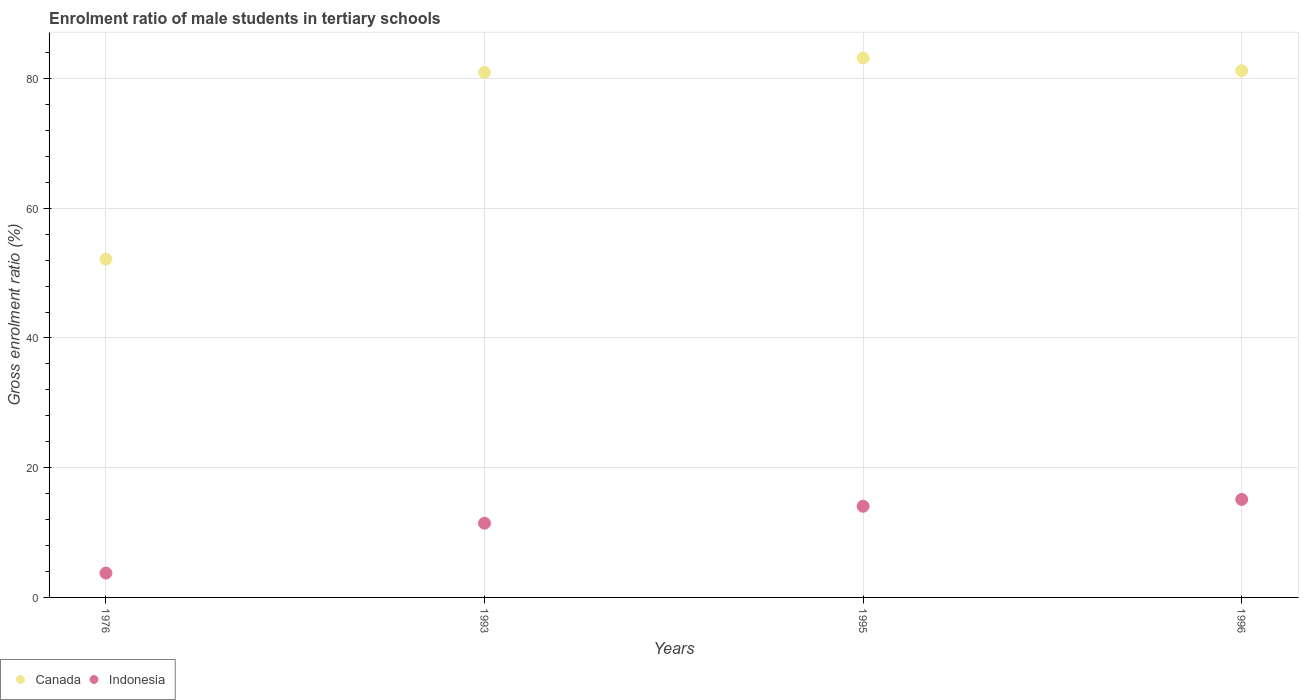What is the enrolment ratio of male students in tertiary schools in Canada in 1996?
Your response must be concise. 81.2. Across all years, what is the maximum enrolment ratio of male students in tertiary schools in Canada?
Ensure brevity in your answer.  83.16. Across all years, what is the minimum enrolment ratio of male students in tertiary schools in Indonesia?
Offer a terse response. 3.75. In which year was the enrolment ratio of male students in tertiary schools in Indonesia maximum?
Provide a succinct answer. 1996. In which year was the enrolment ratio of male students in tertiary schools in Indonesia minimum?
Provide a short and direct response. 1976. What is the total enrolment ratio of male students in tertiary schools in Canada in the graph?
Provide a succinct answer. 297.44. What is the difference between the enrolment ratio of male students in tertiary schools in Canada in 1995 and that in 1996?
Give a very brief answer. 1.96. What is the difference between the enrolment ratio of male students in tertiary schools in Indonesia in 1976 and the enrolment ratio of male students in tertiary schools in Canada in 1996?
Make the answer very short. -77.45. What is the average enrolment ratio of male students in tertiary schools in Indonesia per year?
Keep it short and to the point. 11.09. In the year 1993, what is the difference between the enrolment ratio of male students in tertiary schools in Indonesia and enrolment ratio of male students in tertiary schools in Canada?
Offer a terse response. -69.49. In how many years, is the enrolment ratio of male students in tertiary schools in Canada greater than 40 %?
Ensure brevity in your answer.  4. What is the ratio of the enrolment ratio of male students in tertiary schools in Indonesia in 1976 to that in 1996?
Your answer should be compact. 0.25. Is the difference between the enrolment ratio of male students in tertiary schools in Indonesia in 1976 and 1993 greater than the difference between the enrolment ratio of male students in tertiary schools in Canada in 1976 and 1993?
Your response must be concise. Yes. What is the difference between the highest and the second highest enrolment ratio of male students in tertiary schools in Canada?
Offer a terse response. 1.96. What is the difference between the highest and the lowest enrolment ratio of male students in tertiary schools in Canada?
Keep it short and to the point. 31. In how many years, is the enrolment ratio of male students in tertiary schools in Indonesia greater than the average enrolment ratio of male students in tertiary schools in Indonesia taken over all years?
Your response must be concise. 3. Does the enrolment ratio of male students in tertiary schools in Canada monotonically increase over the years?
Your answer should be very brief. No. How many dotlines are there?
Give a very brief answer. 2. What is the difference between two consecutive major ticks on the Y-axis?
Offer a terse response. 20. Are the values on the major ticks of Y-axis written in scientific E-notation?
Provide a succinct answer. No. Where does the legend appear in the graph?
Your response must be concise. Bottom left. How are the legend labels stacked?
Provide a succinct answer. Horizontal. What is the title of the graph?
Provide a succinct answer. Enrolment ratio of male students in tertiary schools. What is the label or title of the X-axis?
Provide a succinct answer. Years. What is the Gross enrolment ratio (%) in Canada in 1976?
Keep it short and to the point. 52.16. What is the Gross enrolment ratio (%) in Indonesia in 1976?
Provide a succinct answer. 3.75. What is the Gross enrolment ratio (%) in Canada in 1993?
Your response must be concise. 80.93. What is the Gross enrolment ratio (%) in Indonesia in 1993?
Your answer should be very brief. 11.44. What is the Gross enrolment ratio (%) of Canada in 1995?
Offer a terse response. 83.16. What is the Gross enrolment ratio (%) in Indonesia in 1995?
Offer a terse response. 14.06. What is the Gross enrolment ratio (%) of Canada in 1996?
Give a very brief answer. 81.2. What is the Gross enrolment ratio (%) in Indonesia in 1996?
Offer a very short reply. 15.11. Across all years, what is the maximum Gross enrolment ratio (%) in Canada?
Your answer should be very brief. 83.16. Across all years, what is the maximum Gross enrolment ratio (%) of Indonesia?
Keep it short and to the point. 15.11. Across all years, what is the minimum Gross enrolment ratio (%) in Canada?
Give a very brief answer. 52.16. Across all years, what is the minimum Gross enrolment ratio (%) of Indonesia?
Offer a very short reply. 3.75. What is the total Gross enrolment ratio (%) of Canada in the graph?
Make the answer very short. 297.44. What is the total Gross enrolment ratio (%) of Indonesia in the graph?
Your answer should be compact. 44.35. What is the difference between the Gross enrolment ratio (%) in Canada in 1976 and that in 1993?
Offer a terse response. -28.77. What is the difference between the Gross enrolment ratio (%) of Indonesia in 1976 and that in 1993?
Offer a very short reply. -7.69. What is the difference between the Gross enrolment ratio (%) of Canada in 1976 and that in 1995?
Give a very brief answer. -31. What is the difference between the Gross enrolment ratio (%) of Indonesia in 1976 and that in 1995?
Ensure brevity in your answer.  -10.3. What is the difference between the Gross enrolment ratio (%) in Canada in 1976 and that in 1996?
Offer a very short reply. -29.04. What is the difference between the Gross enrolment ratio (%) in Indonesia in 1976 and that in 1996?
Provide a short and direct response. -11.35. What is the difference between the Gross enrolment ratio (%) in Canada in 1993 and that in 1995?
Offer a very short reply. -2.23. What is the difference between the Gross enrolment ratio (%) of Indonesia in 1993 and that in 1995?
Offer a very short reply. -2.62. What is the difference between the Gross enrolment ratio (%) in Canada in 1993 and that in 1996?
Make the answer very short. -0.27. What is the difference between the Gross enrolment ratio (%) in Indonesia in 1993 and that in 1996?
Offer a terse response. -3.66. What is the difference between the Gross enrolment ratio (%) in Canada in 1995 and that in 1996?
Your answer should be very brief. 1.96. What is the difference between the Gross enrolment ratio (%) in Indonesia in 1995 and that in 1996?
Your response must be concise. -1.05. What is the difference between the Gross enrolment ratio (%) of Canada in 1976 and the Gross enrolment ratio (%) of Indonesia in 1993?
Keep it short and to the point. 40.72. What is the difference between the Gross enrolment ratio (%) of Canada in 1976 and the Gross enrolment ratio (%) of Indonesia in 1995?
Offer a very short reply. 38.1. What is the difference between the Gross enrolment ratio (%) in Canada in 1976 and the Gross enrolment ratio (%) in Indonesia in 1996?
Offer a terse response. 37.05. What is the difference between the Gross enrolment ratio (%) of Canada in 1993 and the Gross enrolment ratio (%) of Indonesia in 1995?
Your response must be concise. 66.87. What is the difference between the Gross enrolment ratio (%) of Canada in 1993 and the Gross enrolment ratio (%) of Indonesia in 1996?
Make the answer very short. 65.82. What is the difference between the Gross enrolment ratio (%) in Canada in 1995 and the Gross enrolment ratio (%) in Indonesia in 1996?
Offer a very short reply. 68.05. What is the average Gross enrolment ratio (%) in Canada per year?
Your answer should be compact. 74.36. What is the average Gross enrolment ratio (%) in Indonesia per year?
Your answer should be very brief. 11.09. In the year 1976, what is the difference between the Gross enrolment ratio (%) of Canada and Gross enrolment ratio (%) of Indonesia?
Your response must be concise. 48.41. In the year 1993, what is the difference between the Gross enrolment ratio (%) of Canada and Gross enrolment ratio (%) of Indonesia?
Ensure brevity in your answer.  69.49. In the year 1995, what is the difference between the Gross enrolment ratio (%) in Canada and Gross enrolment ratio (%) in Indonesia?
Offer a terse response. 69.1. In the year 1996, what is the difference between the Gross enrolment ratio (%) in Canada and Gross enrolment ratio (%) in Indonesia?
Keep it short and to the point. 66.09. What is the ratio of the Gross enrolment ratio (%) in Canada in 1976 to that in 1993?
Your answer should be compact. 0.64. What is the ratio of the Gross enrolment ratio (%) in Indonesia in 1976 to that in 1993?
Keep it short and to the point. 0.33. What is the ratio of the Gross enrolment ratio (%) in Canada in 1976 to that in 1995?
Your answer should be compact. 0.63. What is the ratio of the Gross enrolment ratio (%) of Indonesia in 1976 to that in 1995?
Keep it short and to the point. 0.27. What is the ratio of the Gross enrolment ratio (%) in Canada in 1976 to that in 1996?
Provide a short and direct response. 0.64. What is the ratio of the Gross enrolment ratio (%) of Indonesia in 1976 to that in 1996?
Offer a terse response. 0.25. What is the ratio of the Gross enrolment ratio (%) in Canada in 1993 to that in 1995?
Your answer should be very brief. 0.97. What is the ratio of the Gross enrolment ratio (%) of Indonesia in 1993 to that in 1995?
Ensure brevity in your answer.  0.81. What is the ratio of the Gross enrolment ratio (%) in Indonesia in 1993 to that in 1996?
Your answer should be compact. 0.76. What is the ratio of the Gross enrolment ratio (%) of Canada in 1995 to that in 1996?
Make the answer very short. 1.02. What is the ratio of the Gross enrolment ratio (%) of Indonesia in 1995 to that in 1996?
Give a very brief answer. 0.93. What is the difference between the highest and the second highest Gross enrolment ratio (%) in Canada?
Keep it short and to the point. 1.96. What is the difference between the highest and the second highest Gross enrolment ratio (%) of Indonesia?
Your response must be concise. 1.05. What is the difference between the highest and the lowest Gross enrolment ratio (%) in Canada?
Ensure brevity in your answer.  31. What is the difference between the highest and the lowest Gross enrolment ratio (%) of Indonesia?
Ensure brevity in your answer.  11.35. 